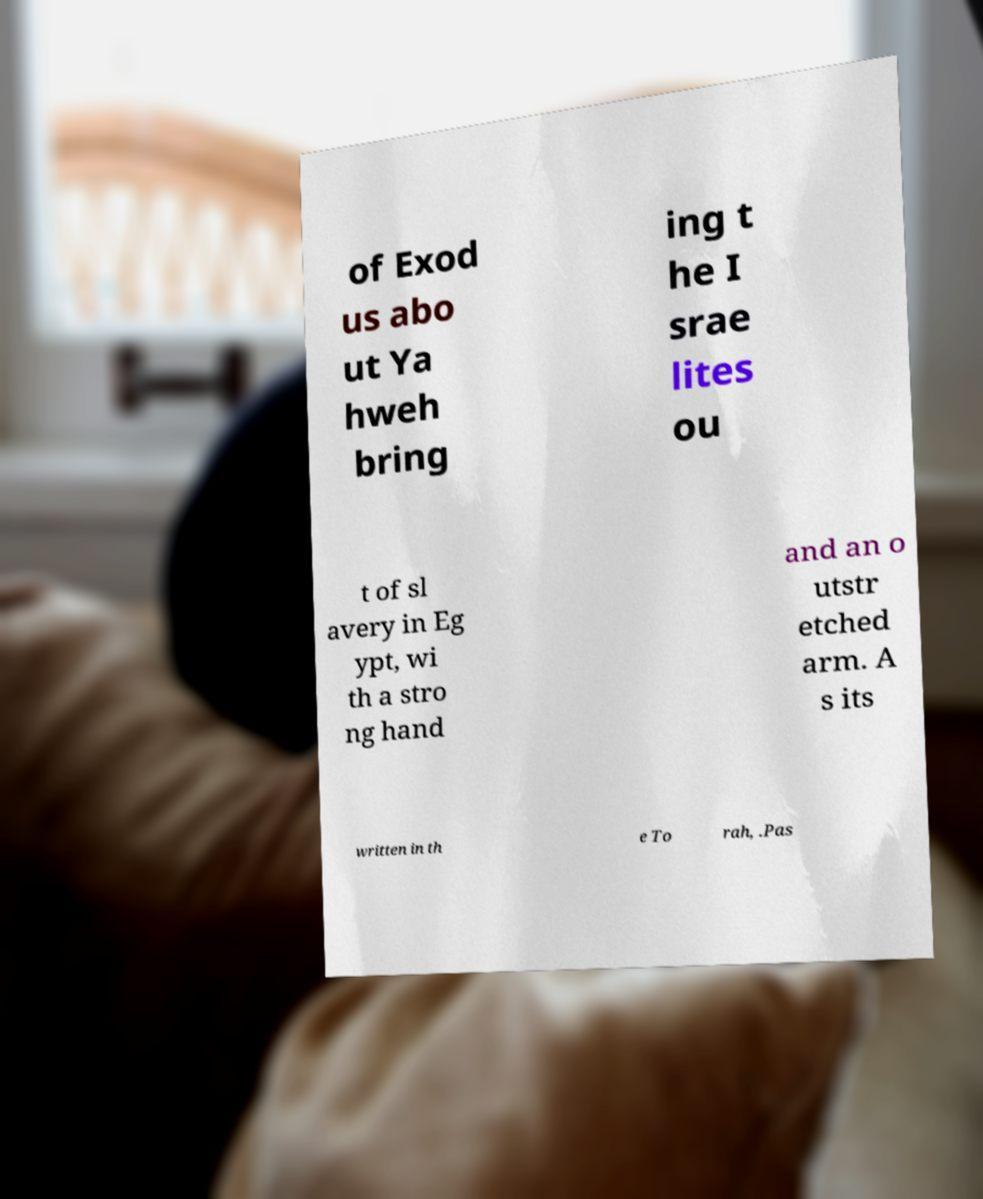Can you read and provide the text displayed in the image?This photo seems to have some interesting text. Can you extract and type it out for me? of Exod us abo ut Ya hweh bring ing t he I srae lites ou t of sl avery in Eg ypt, wi th a stro ng hand and an o utstr etched arm. A s its written in th e To rah, .Pas 